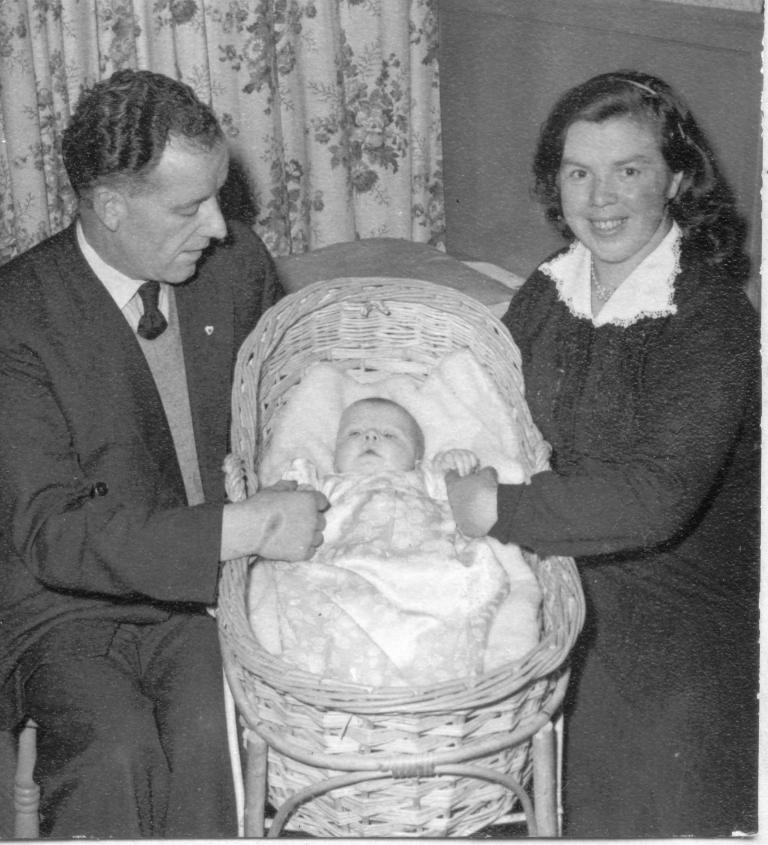What is the color scheme of the image? The image is black and white. How many people are in the image? There is a man and a woman in the image. What are the man and woman doing in the image? Both the man and woman are sitting on chairs. What can be seen in the middle of the image? There is a baby in a cradle in the middle of the image. What type of veil is the man wearing in the image? There is no veil present in the image; both the man and woman are dressed in regular clothing. 